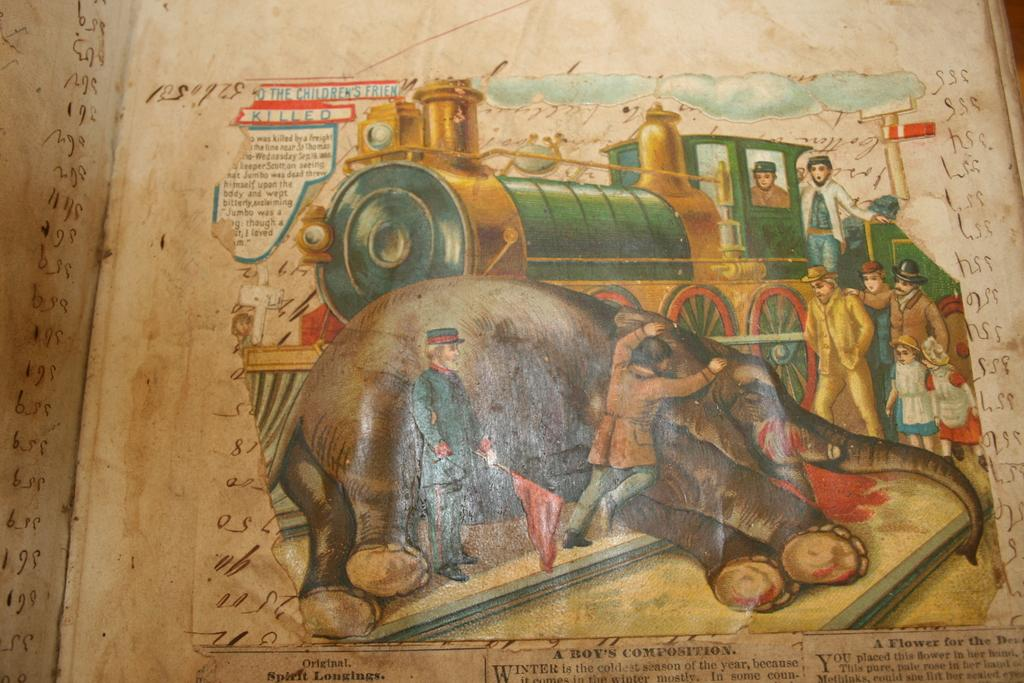Provide a one-sentence caption for the provided image. a book with a train on it that says killed at the top. 